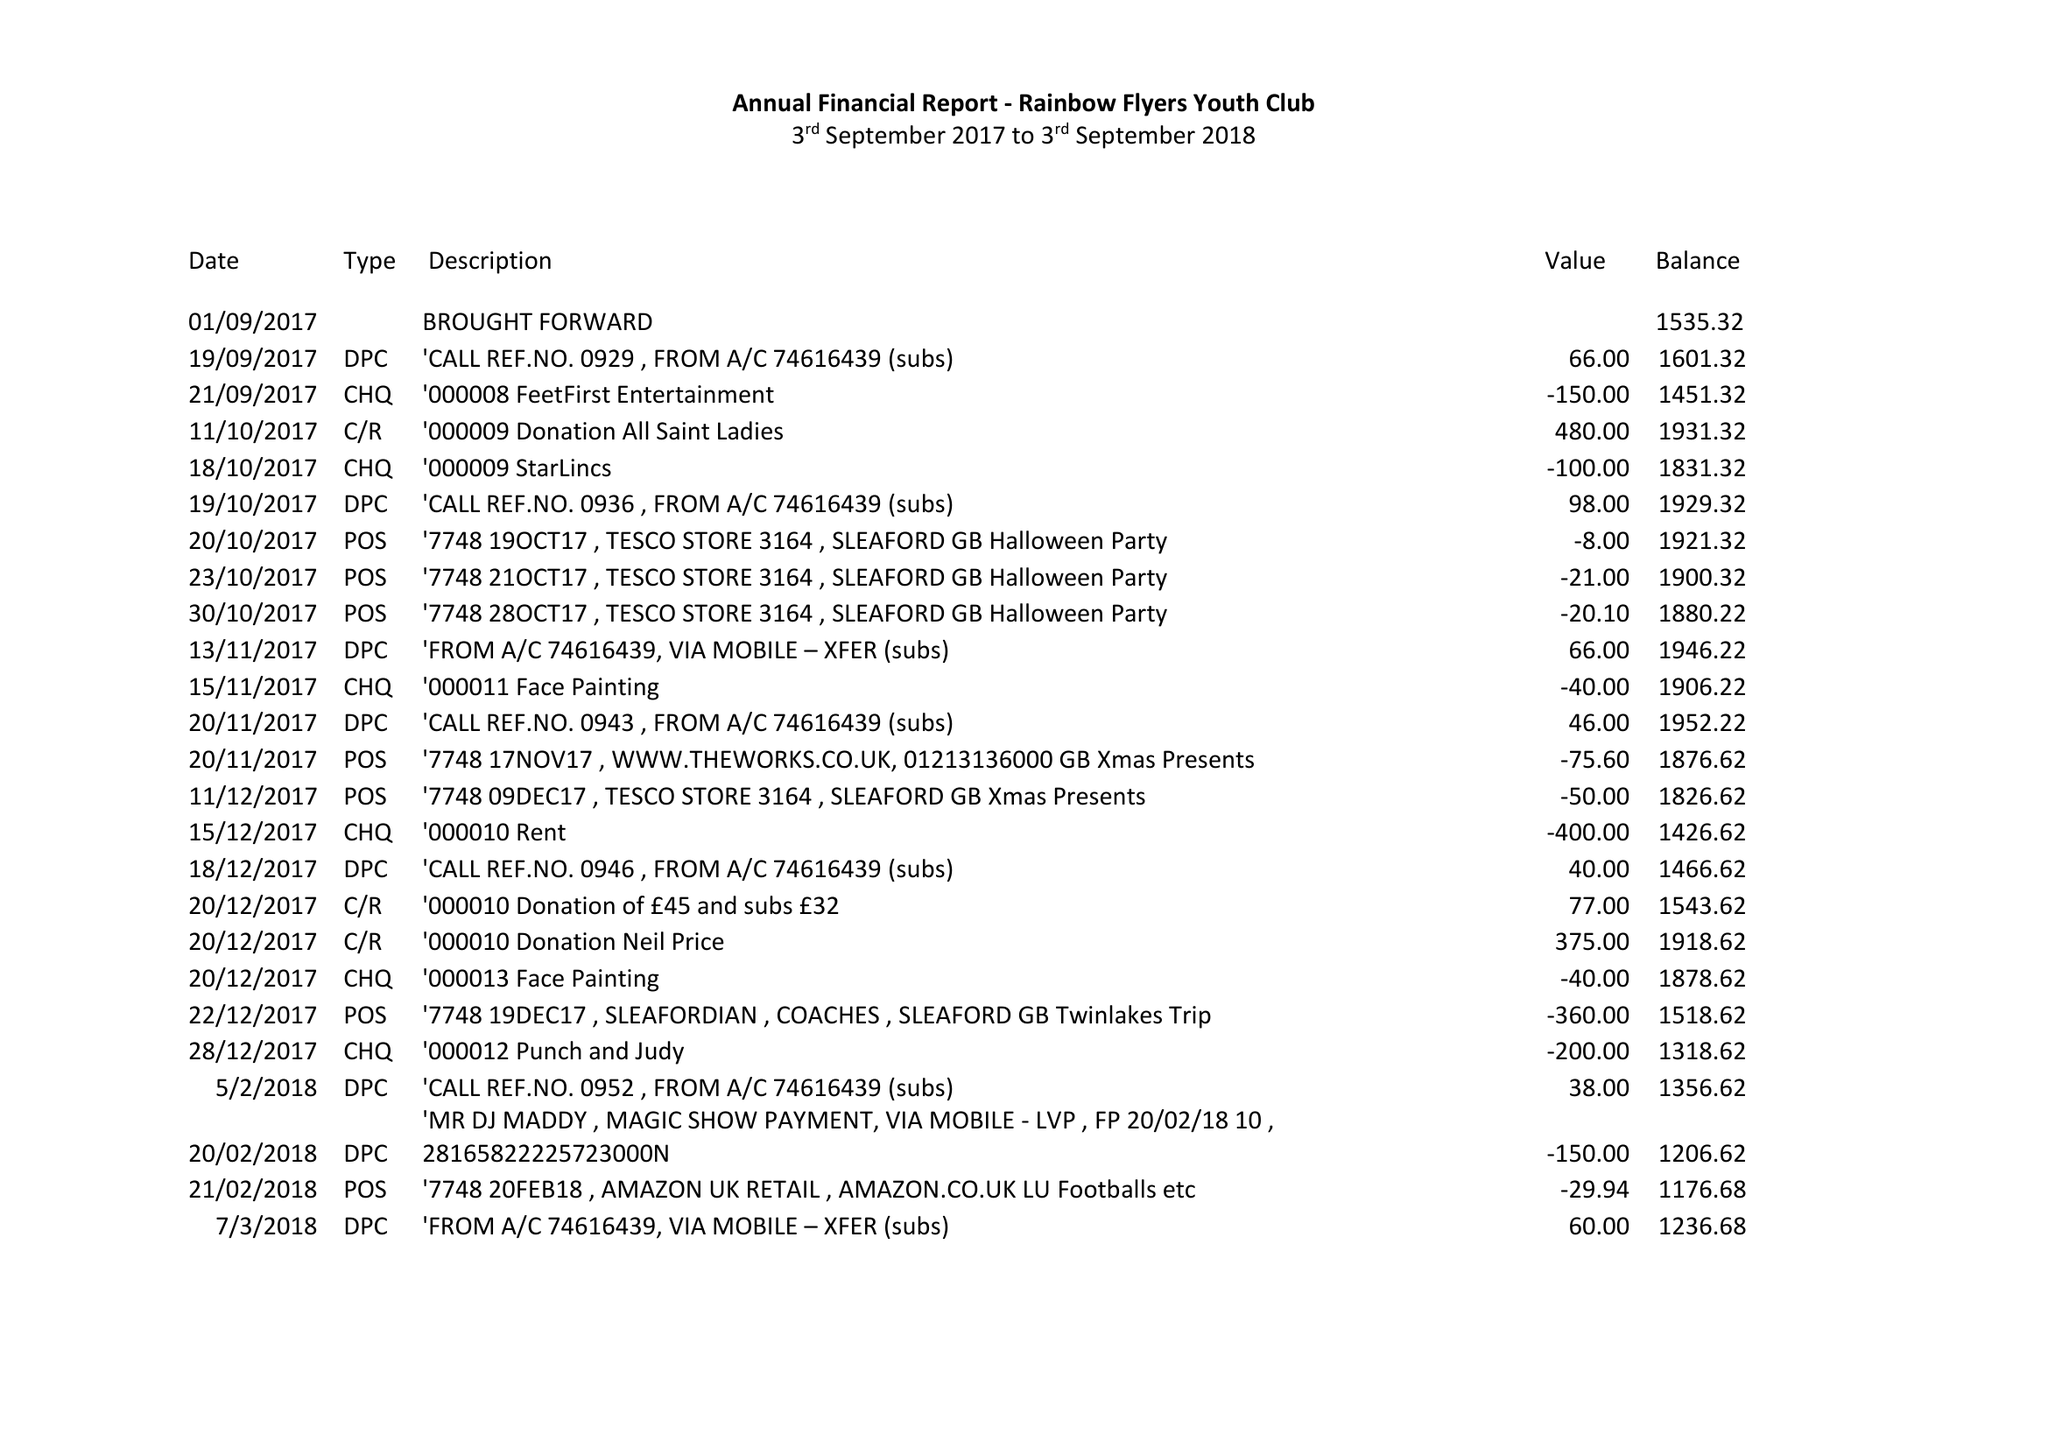What is the value for the charity_name?
Answer the question using a single word or phrase. Rainbow Flyers Youth Club 